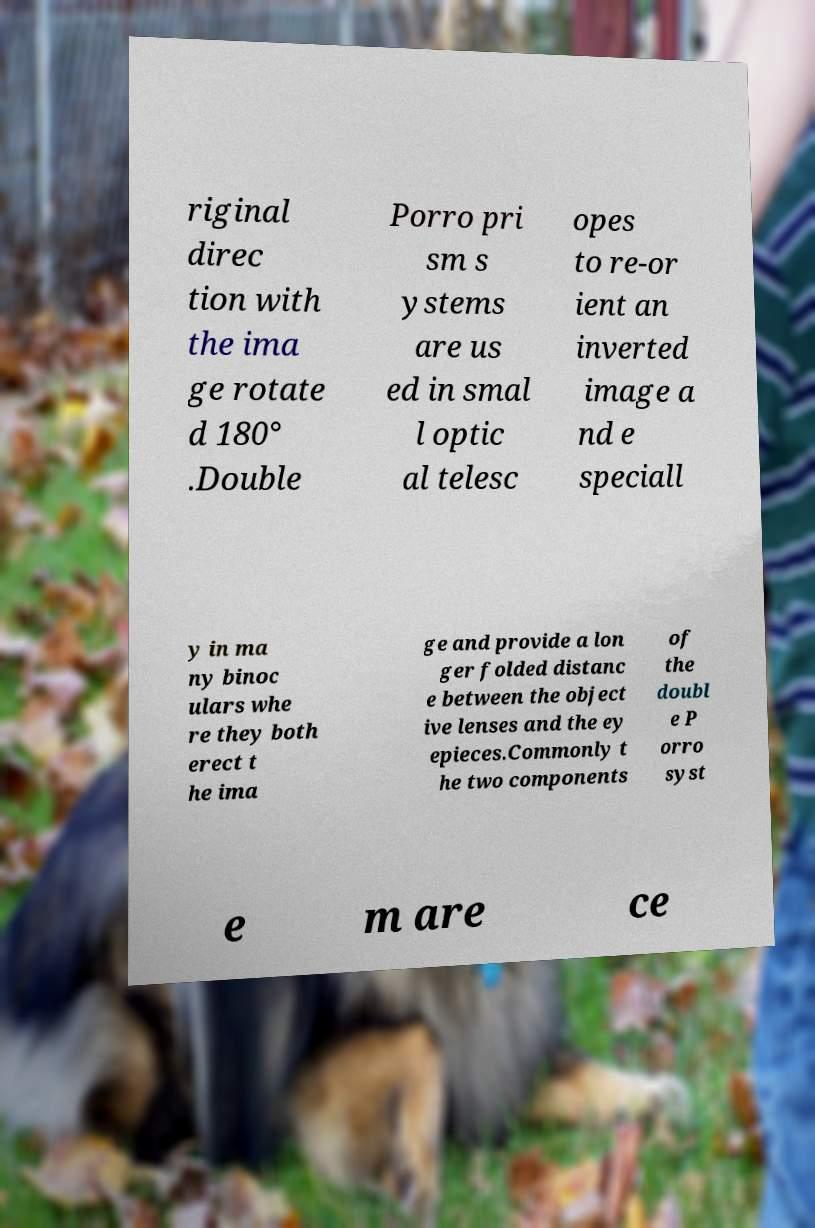Can you accurately transcribe the text from the provided image for me? riginal direc tion with the ima ge rotate d 180° .Double Porro pri sm s ystems are us ed in smal l optic al telesc opes to re-or ient an inverted image a nd e speciall y in ma ny binoc ulars whe re they both erect t he ima ge and provide a lon ger folded distanc e between the object ive lenses and the ey epieces.Commonly t he two components of the doubl e P orro syst e m are ce 